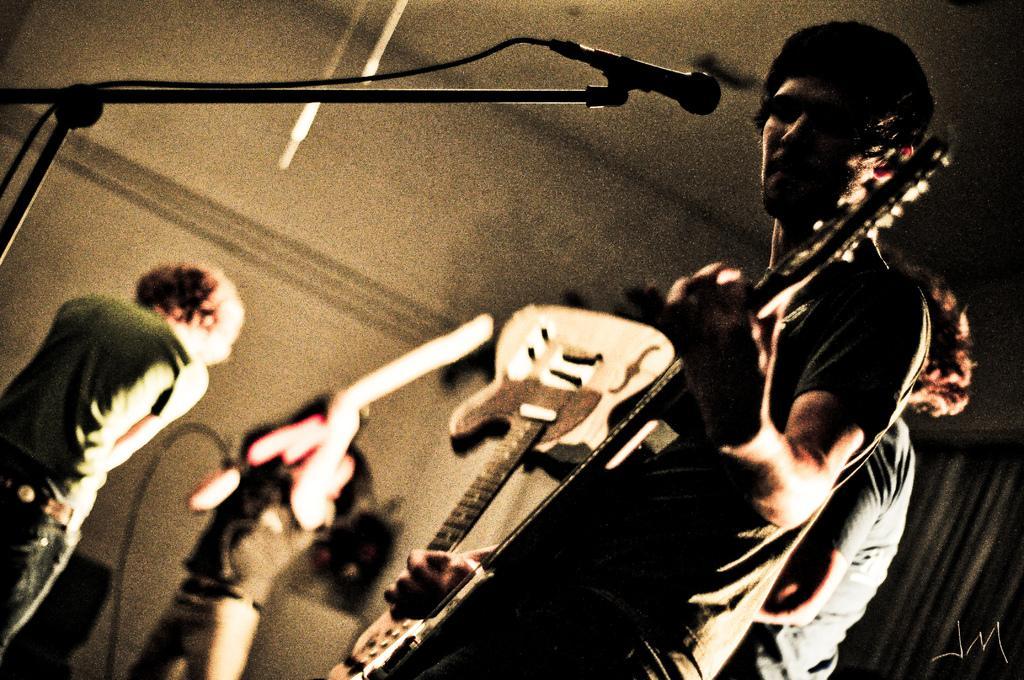In one or two sentences, can you explain what this image depicts? It looks like a music show there are some people standing and playing the musical instruments the person who is standing first is holding guitar in his hand there is a mike in front of him , beside to him someone is holding guitar upside down. 